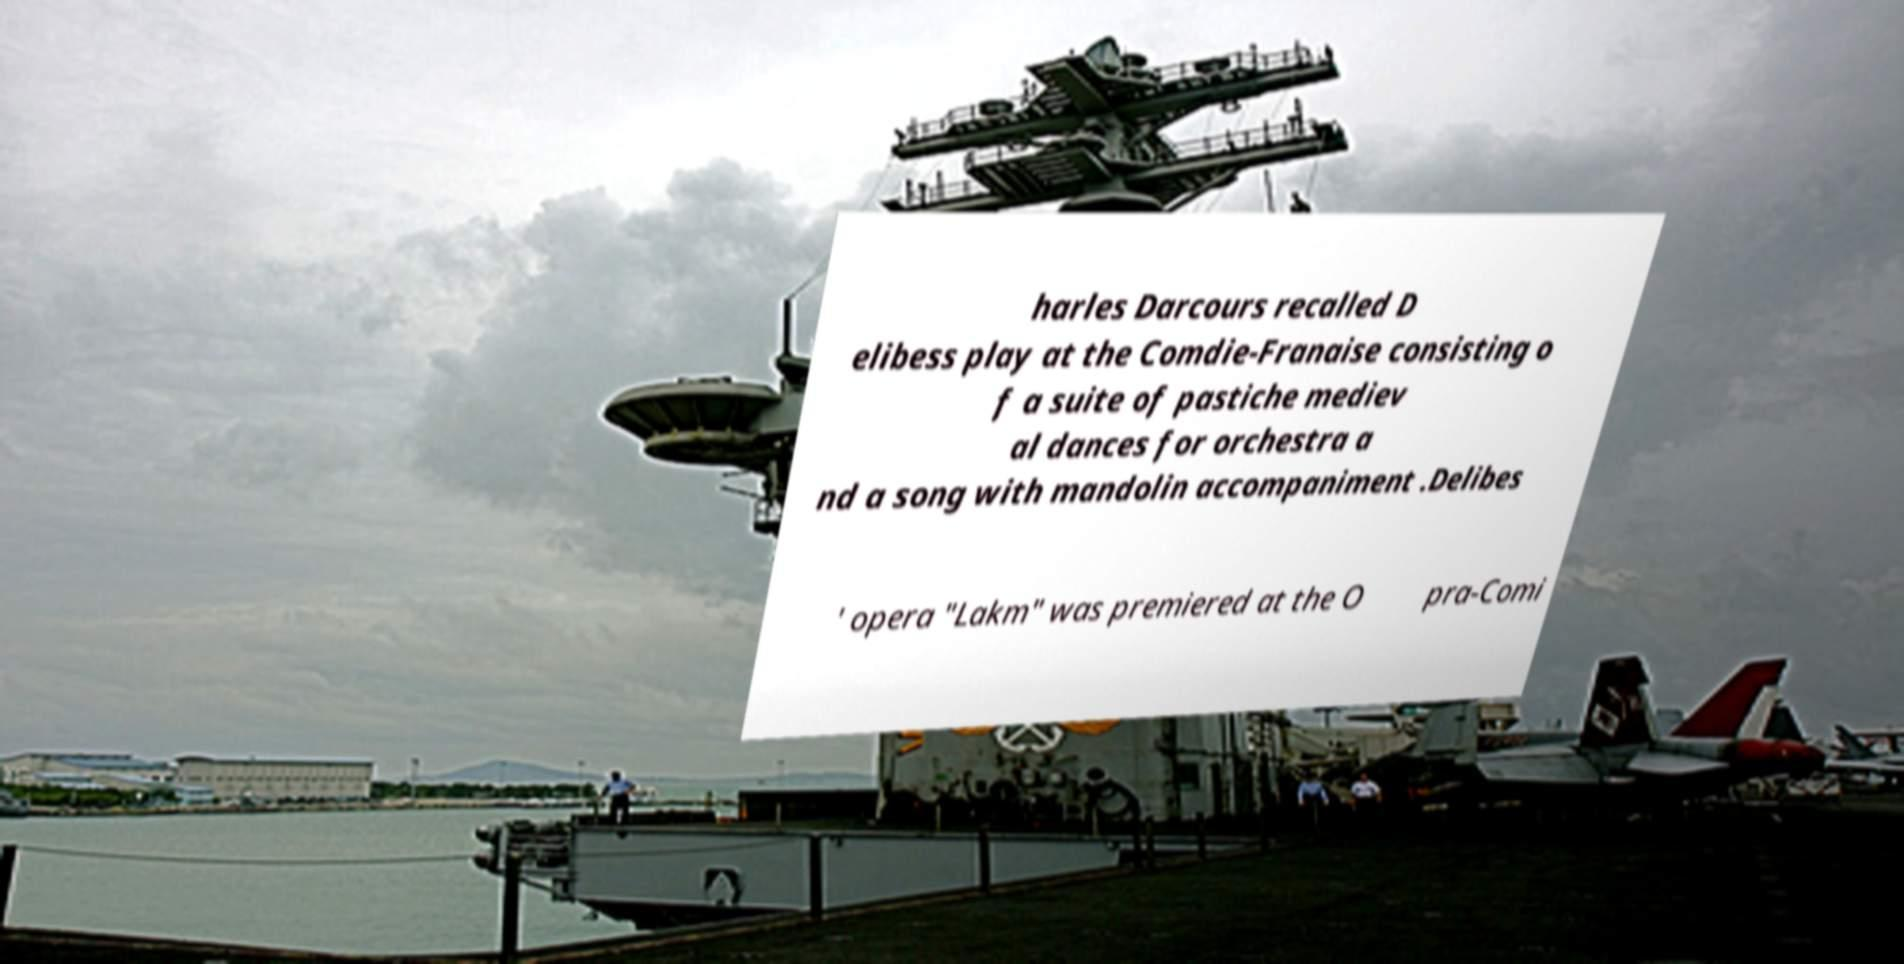Could you assist in decoding the text presented in this image and type it out clearly? harles Darcours recalled D elibess play at the Comdie-Franaise consisting o f a suite of pastiche mediev al dances for orchestra a nd a song with mandolin accompaniment .Delibes ' opera "Lakm" was premiered at the O pra-Comi 